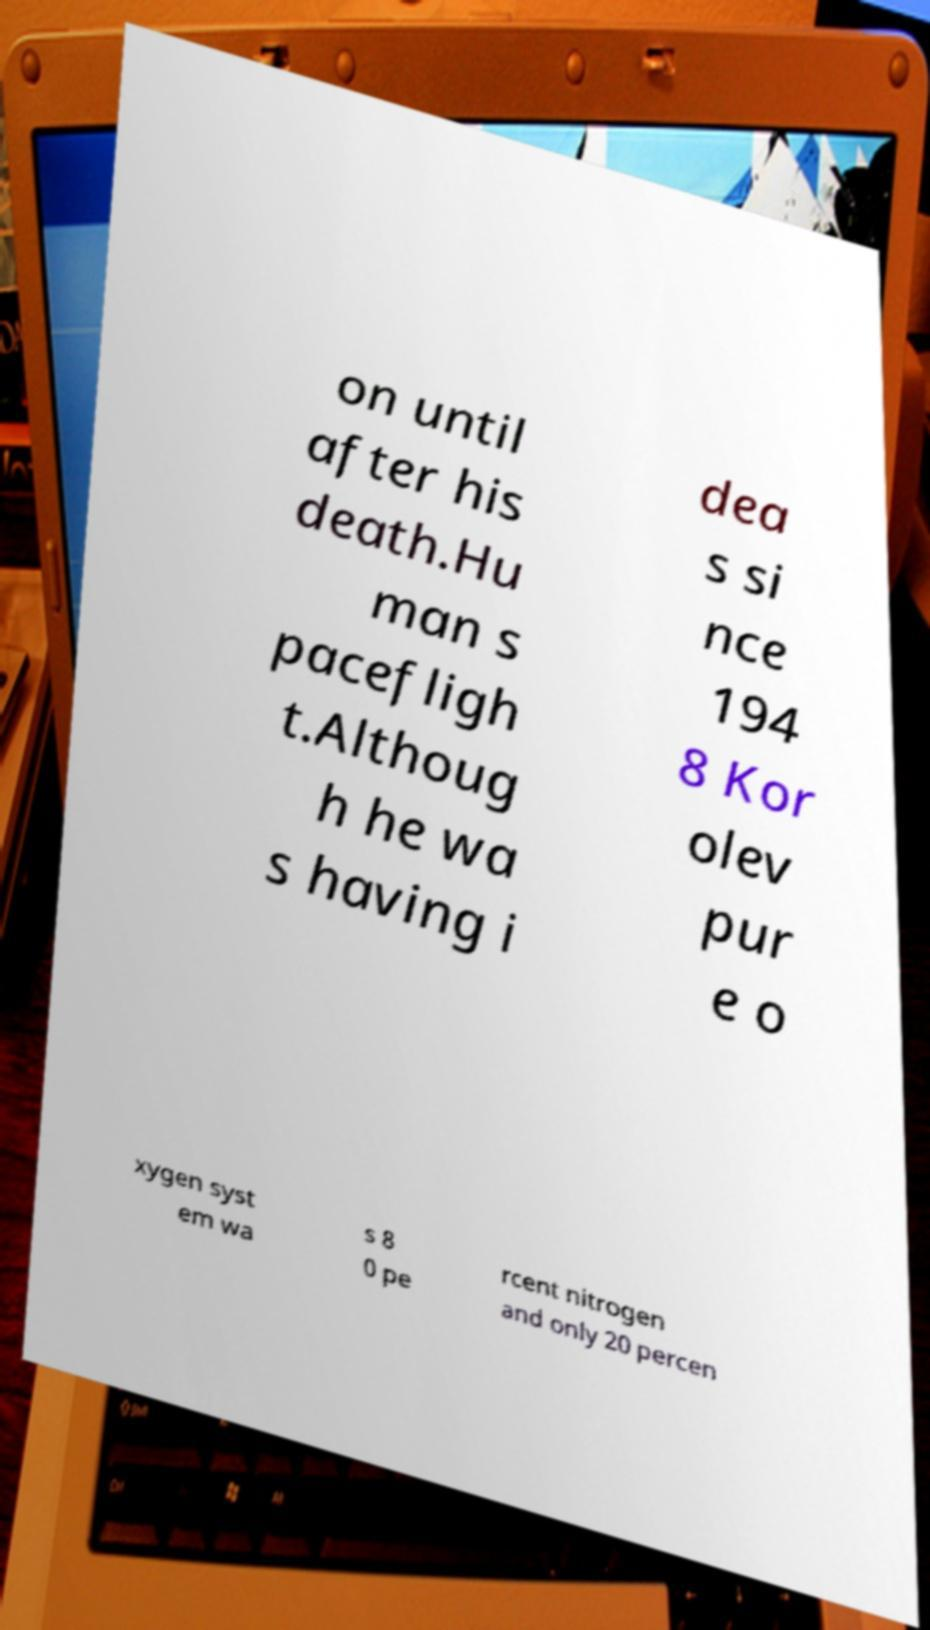Could you extract and type out the text from this image? on until after his death.Hu man s pacefligh t.Althoug h he wa s having i dea s si nce 194 8 Kor olev pur e o xygen syst em wa s 8 0 pe rcent nitrogen and only 20 percen 